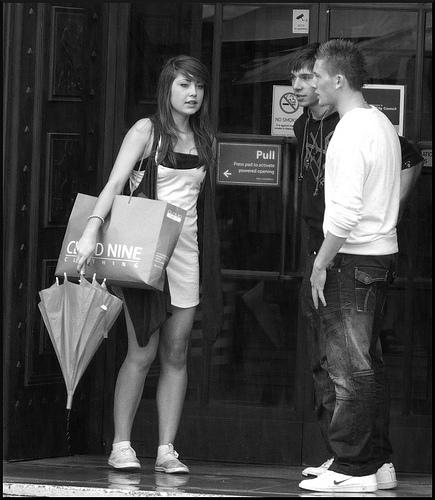What is the girl wearing on her feet? The girl is wearing small grey shoes on her feet. Identify any warning signs located in the scene. There is a no smoking sign and a notice for security cameras. What is the accessory on the woman's arm? The woman is wearing a small bracelet on her arm. Describe any interactions or conversations happening in the image. Two men are talking to a shopping woman who is carrying a bag and an umbrella. What is the condition of the sidewalk? The sidewalk is wet due to rain. Can you tell me what is written on the woman's shopping bag? White writing is present on the woman's shopping bag. What is the girl carrying and how is she carrying it? The girl is carrying a shopping bag on her shoulder and an umbrella in her hand. Could you explain the dress style of the young man? The young man is dressed in a white long sleeve shirt and blue jeans. What type of sign is on the door? There is a pull sign and a no smoking sign on the door. Please describe the sneakers the man is wearing. The man is wearing white Nike sneakers. Can you see a dog walking beside the girl with the umbrella? There is no mention of a dog in the image, so it is a misleading instruction with an interrogative sentence. Identify the tall tree next to the store entrance. No, it's not mentioned in the image. Is there a bird perched on the no smoking sign? There is no mention of a bird in the image, so it is a misleading instruction with an interrogative sentence. 